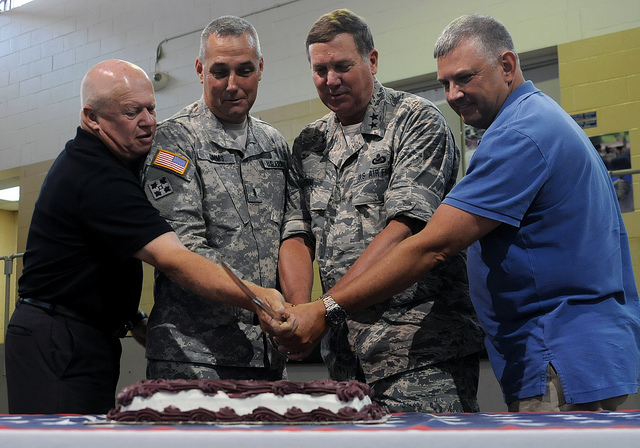What details can you provide about the cake in the image? The cake in the image is rectangular, covered with white frosting, and has a border that appears to be made of cream or icing. It resembles an American flag design, with stripes and a blue field, which may indicate a patriotic theme for the event. What might the significance of the cake design be? The cake's design, emulating the American flag, likely holds patriotic significance, and it could be celebrating a national holiday, or honoring military personnel or achievements. 